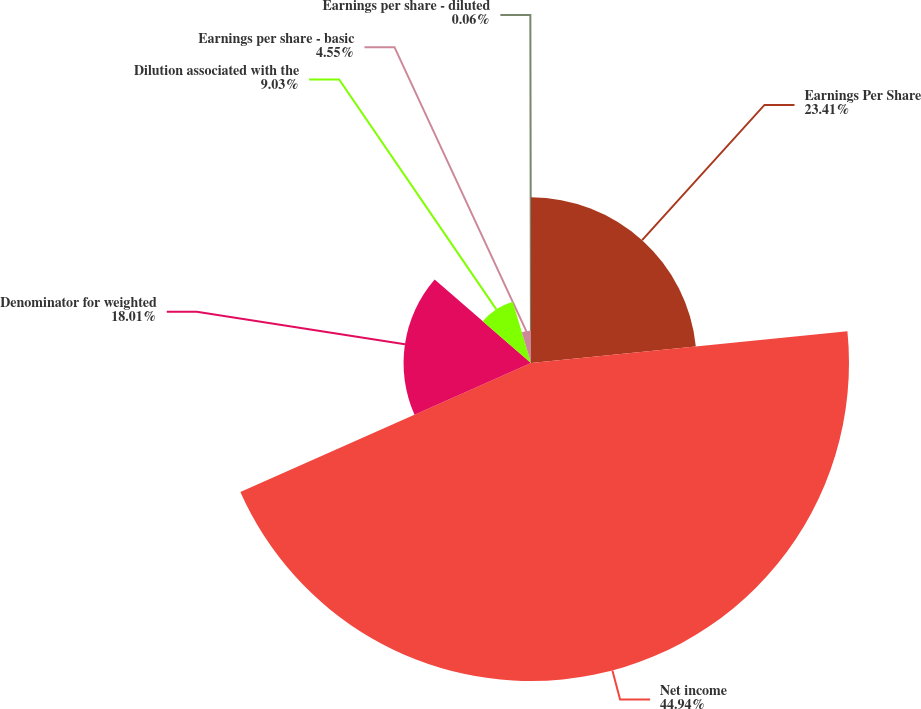Convert chart. <chart><loc_0><loc_0><loc_500><loc_500><pie_chart><fcel>Earnings Per Share<fcel>Net income<fcel>Denominator for weighted<fcel>Dilution associated with the<fcel>Earnings per share - basic<fcel>Earnings per share - diluted<nl><fcel>23.41%<fcel>44.94%<fcel>18.01%<fcel>9.03%<fcel>4.55%<fcel>0.06%<nl></chart> 